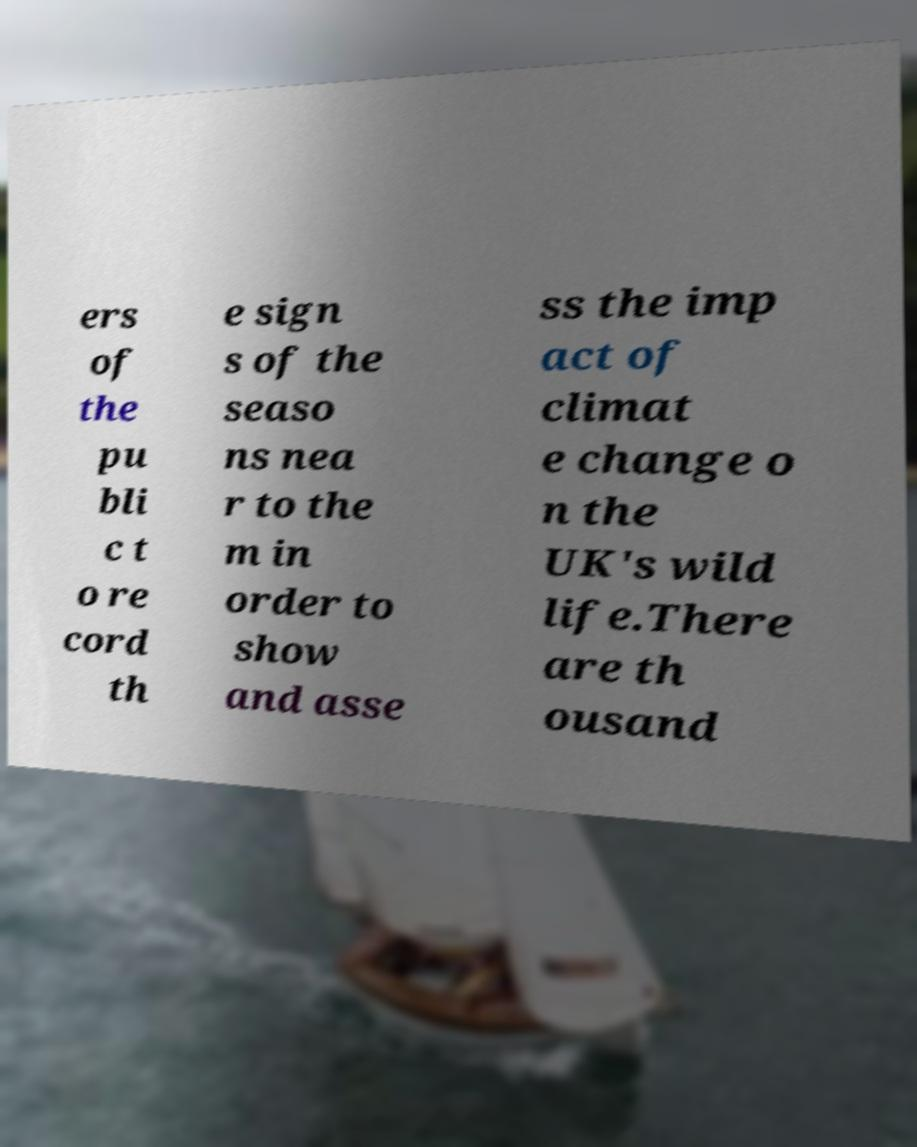Can you accurately transcribe the text from the provided image for me? ers of the pu bli c t o re cord th e sign s of the seaso ns nea r to the m in order to show and asse ss the imp act of climat e change o n the UK's wild life.There are th ousand 